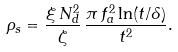<formula> <loc_0><loc_0><loc_500><loc_500>\rho _ { s } = \frac { \xi \, N _ { d } ^ { 2 } } { \zeta } \, \frac { \pi \, f _ { a } ^ { 2 } \ln ( t / \delta ) } { t ^ { 2 } } .</formula> 